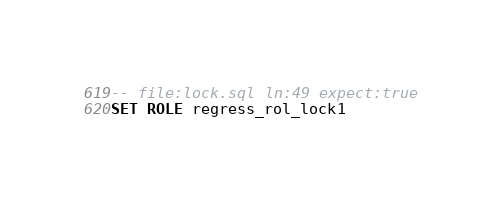<code> <loc_0><loc_0><loc_500><loc_500><_SQL_>-- file:lock.sql ln:49 expect:true
SET ROLE regress_rol_lock1
</code> 